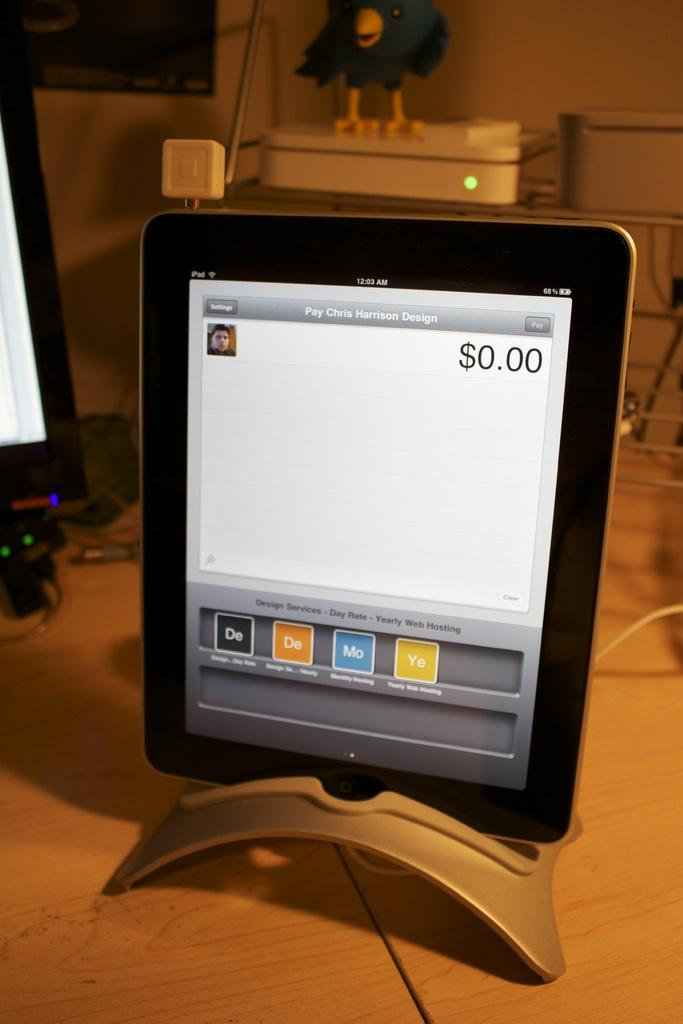<image>
Relay a brief, clear account of the picture shown. An electronic screen displaying Pay Chris Harrison Design but $0.00 showing. 